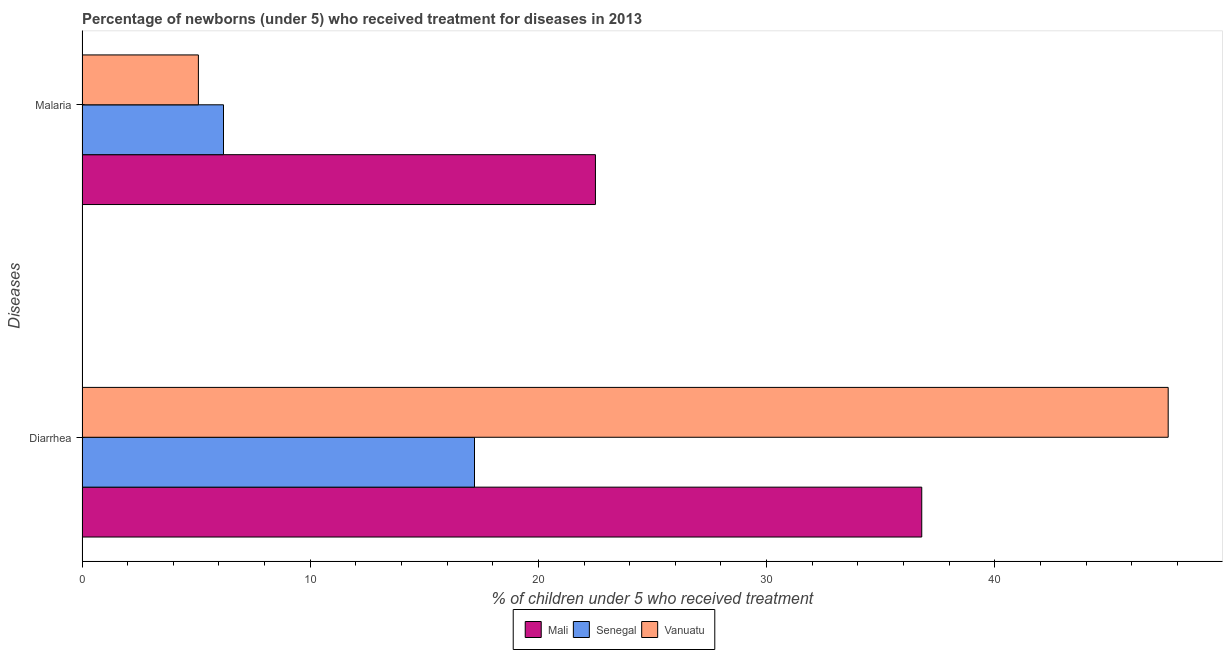How many groups of bars are there?
Provide a short and direct response. 2. How many bars are there on the 1st tick from the top?
Ensure brevity in your answer.  3. How many bars are there on the 2nd tick from the bottom?
Offer a terse response. 3. What is the label of the 1st group of bars from the top?
Provide a short and direct response. Malaria. Across all countries, what is the maximum percentage of children who received treatment for diarrhoea?
Your answer should be compact. 47.6. In which country was the percentage of children who received treatment for diarrhoea maximum?
Your answer should be very brief. Vanuatu. In which country was the percentage of children who received treatment for diarrhoea minimum?
Give a very brief answer. Senegal. What is the total percentage of children who received treatment for diarrhoea in the graph?
Make the answer very short. 101.6. What is the difference between the percentage of children who received treatment for diarrhoea in Senegal and that in Mali?
Offer a very short reply. -19.6. What is the difference between the percentage of children who received treatment for diarrhoea in Vanuatu and the percentage of children who received treatment for malaria in Senegal?
Keep it short and to the point. 41.4. What is the average percentage of children who received treatment for malaria per country?
Provide a succinct answer. 11.27. What is the difference between the percentage of children who received treatment for diarrhoea and percentage of children who received treatment for malaria in Vanuatu?
Make the answer very short. 42.5. What is the ratio of the percentage of children who received treatment for diarrhoea in Vanuatu to that in Mali?
Provide a succinct answer. 1.29. Is the percentage of children who received treatment for diarrhoea in Mali less than that in Vanuatu?
Make the answer very short. Yes. What does the 2nd bar from the top in Malaria represents?
Provide a short and direct response. Senegal. What does the 1st bar from the bottom in Malaria represents?
Provide a succinct answer. Mali. How many bars are there?
Keep it short and to the point. 6. Are all the bars in the graph horizontal?
Make the answer very short. Yes. How many countries are there in the graph?
Provide a succinct answer. 3. How many legend labels are there?
Keep it short and to the point. 3. How are the legend labels stacked?
Ensure brevity in your answer.  Horizontal. What is the title of the graph?
Offer a terse response. Percentage of newborns (under 5) who received treatment for diseases in 2013. Does "Comoros" appear as one of the legend labels in the graph?
Provide a succinct answer. No. What is the label or title of the X-axis?
Provide a short and direct response. % of children under 5 who received treatment. What is the label or title of the Y-axis?
Keep it short and to the point. Diseases. What is the % of children under 5 who received treatment in Mali in Diarrhea?
Provide a succinct answer. 36.8. What is the % of children under 5 who received treatment of Vanuatu in Diarrhea?
Keep it short and to the point. 47.6. What is the % of children under 5 who received treatment of Senegal in Malaria?
Provide a succinct answer. 6.2. What is the % of children under 5 who received treatment in Vanuatu in Malaria?
Keep it short and to the point. 5.1. Across all Diseases, what is the maximum % of children under 5 who received treatment in Mali?
Your answer should be compact. 36.8. Across all Diseases, what is the maximum % of children under 5 who received treatment of Senegal?
Provide a succinct answer. 17.2. Across all Diseases, what is the maximum % of children under 5 who received treatment of Vanuatu?
Provide a short and direct response. 47.6. Across all Diseases, what is the minimum % of children under 5 who received treatment in Mali?
Offer a terse response. 22.5. Across all Diseases, what is the minimum % of children under 5 who received treatment of Vanuatu?
Give a very brief answer. 5.1. What is the total % of children under 5 who received treatment in Mali in the graph?
Keep it short and to the point. 59.3. What is the total % of children under 5 who received treatment in Senegal in the graph?
Give a very brief answer. 23.4. What is the total % of children under 5 who received treatment in Vanuatu in the graph?
Ensure brevity in your answer.  52.7. What is the difference between the % of children under 5 who received treatment of Mali in Diarrhea and that in Malaria?
Ensure brevity in your answer.  14.3. What is the difference between the % of children under 5 who received treatment of Senegal in Diarrhea and that in Malaria?
Provide a succinct answer. 11. What is the difference between the % of children under 5 who received treatment of Vanuatu in Diarrhea and that in Malaria?
Offer a terse response. 42.5. What is the difference between the % of children under 5 who received treatment in Mali in Diarrhea and the % of children under 5 who received treatment in Senegal in Malaria?
Your response must be concise. 30.6. What is the difference between the % of children under 5 who received treatment in Mali in Diarrhea and the % of children under 5 who received treatment in Vanuatu in Malaria?
Provide a short and direct response. 31.7. What is the average % of children under 5 who received treatment in Mali per Diseases?
Make the answer very short. 29.65. What is the average % of children under 5 who received treatment of Vanuatu per Diseases?
Provide a short and direct response. 26.35. What is the difference between the % of children under 5 who received treatment in Mali and % of children under 5 who received treatment in Senegal in Diarrhea?
Keep it short and to the point. 19.6. What is the difference between the % of children under 5 who received treatment in Senegal and % of children under 5 who received treatment in Vanuatu in Diarrhea?
Provide a short and direct response. -30.4. What is the difference between the % of children under 5 who received treatment of Mali and % of children under 5 who received treatment of Vanuatu in Malaria?
Ensure brevity in your answer.  17.4. What is the difference between the % of children under 5 who received treatment in Senegal and % of children under 5 who received treatment in Vanuatu in Malaria?
Your answer should be very brief. 1.1. What is the ratio of the % of children under 5 who received treatment of Mali in Diarrhea to that in Malaria?
Your answer should be compact. 1.64. What is the ratio of the % of children under 5 who received treatment of Senegal in Diarrhea to that in Malaria?
Offer a very short reply. 2.77. What is the ratio of the % of children under 5 who received treatment in Vanuatu in Diarrhea to that in Malaria?
Your response must be concise. 9.33. What is the difference between the highest and the second highest % of children under 5 who received treatment in Mali?
Your answer should be compact. 14.3. What is the difference between the highest and the second highest % of children under 5 who received treatment in Vanuatu?
Provide a short and direct response. 42.5. What is the difference between the highest and the lowest % of children under 5 who received treatment in Senegal?
Give a very brief answer. 11. What is the difference between the highest and the lowest % of children under 5 who received treatment in Vanuatu?
Make the answer very short. 42.5. 